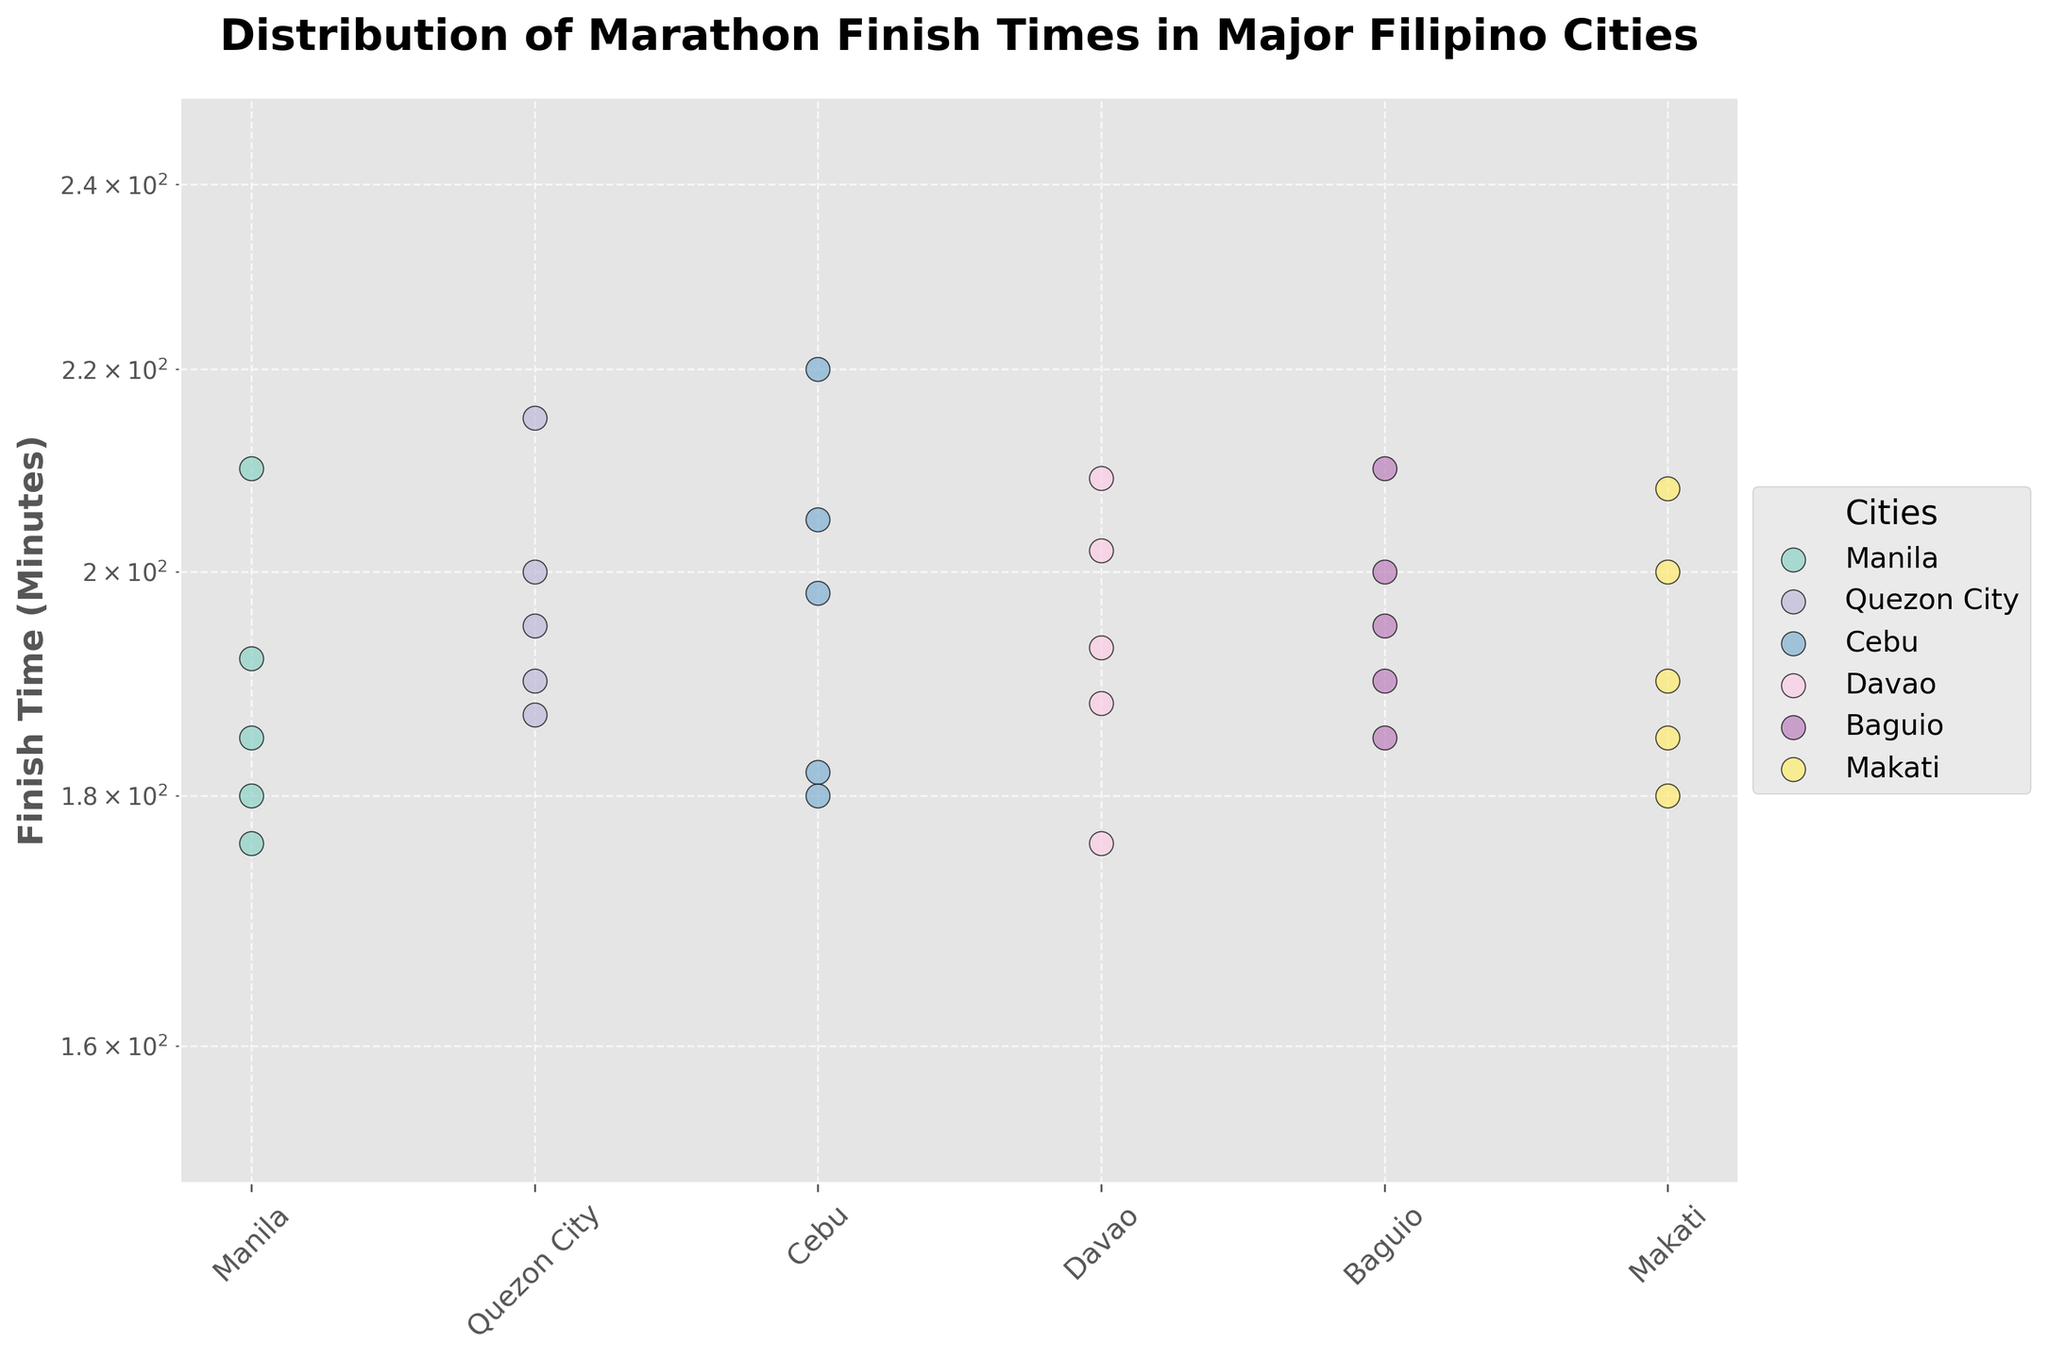What is the title of the plot? The title of the plot is located at the top, reading 'Distribution of Marathon Finish Times in Major Filipino Cities'.
Answer: Distribution of Marathon Finish Times in Major Filipino Cities What is the vertical axis labeled? The label for the vertical axis is 'Finish Time (Minutes)'.
Answer: Finish Time (Minutes) How many different cities are represented in the plot? By looking at the legend on the right side of the plot, we see that the plot represents six different cities: Manila, Quezon City, Cebu, Davao, Baguio, and Makati.
Answer: 6 Which city's finish times show the most variability? To identify the city with the most variability, we look for the city with data points scattered over the widest vertical range. Cebu and Davao seem to have the most spread out points.
Answer: Cebu and Davao Are there any cities with finish times below 180 minutes? We examine the plot to see if any data points are below the 180-minute mark. Upon inspection, no city has finish times below 180 minutes.
Answer: No For which cities are the median finish times the same? By visually estimating the median position (middle point) of the data points for each city, we notice that the medians for both Manila and Baguio appear to be around 190 minutes.
Answer: Manila and Baguio Which city has the highest finish time? The highest finish time is seen in the city with the uppermost data point. Cebu has a finish time of 220 minutes.
Answer: Cebu How does the y-axis scaling affect the interpretation of the data? The y-axis uses a log scale which spaces the finish times unevenly, making it easier to visualize data points with smaller differences relative to each other. This scaling helps highlight differences in lower finish times more clearly.
Answer: Log scale highlights differences What is the range of finish times for Quezon City? We look at the lowest and highest data points for Quezon City: 187 and 215 minutes. The range is the difference between these points: 215 - 187 = 28 minutes.
Answer: 28 minutes 